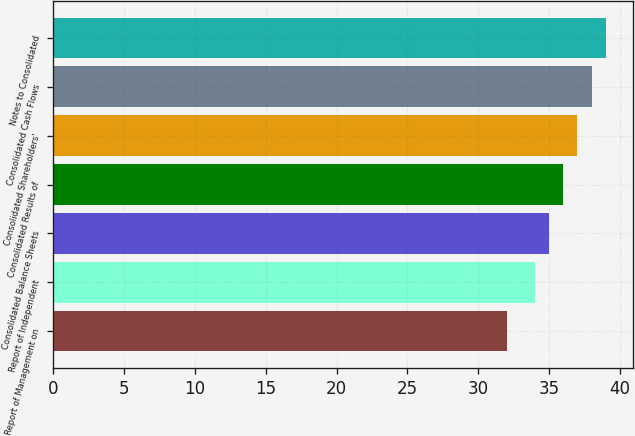Convert chart. <chart><loc_0><loc_0><loc_500><loc_500><bar_chart><fcel>Report of Management on<fcel>Report of Independent<fcel>Consolidated Balance Sheets<fcel>Consolidated Results of<fcel>Consolidated Shareholders'<fcel>Consolidated Cash Flows<fcel>Notes to Consolidated<nl><fcel>32<fcel>34<fcel>35<fcel>36<fcel>37<fcel>38<fcel>39<nl></chart> 